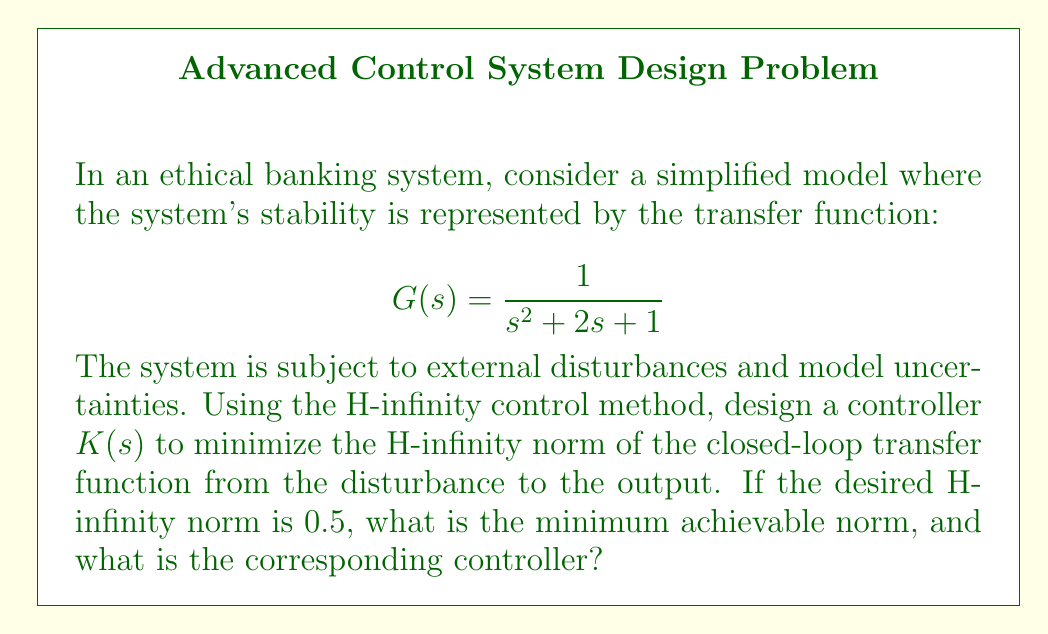Help me with this question. To solve this problem using the H-infinity control method, we follow these steps:

1) First, we need to express the system in state-space form. The transfer function $G(s) = \frac{1}{s^2 + 2s + 1}$ can be represented as:

   $$\begin{aligned}
   \dot{x} &= Ax + Bu \\
   y &= Cx + Du
   \end{aligned}$$

   Where:
   $$A = \begin{bmatrix} 0 & 1 \\ -1 & -2 \end{bmatrix}, \quad B = \begin{bmatrix} 0 \\ 1 \end{bmatrix}, \quad C = \begin{bmatrix} 1 & 0 \end{bmatrix}, \quad D = 0$$

2) The H-infinity control problem is to find a controller $K(s)$ that minimizes:

   $$\gamma = \|T_{zw}\|_\infty$$

   Where $T_{zw}$ is the closed-loop transfer function from the disturbance $w$ to the output $z$.

3) We use the state-feedback approach to design the controller. The controller will have the form:

   $$K(s) = F(sI - A + BF)^{-1}B$$

   Where $F$ is the state-feedback gain matrix.

4) To find $F$, we need to solve the algebraic Riccati equation:

   $$A^TP + PA - PBB^TP + \gamma^{-2}C^TC = 0$$

5) We start with $\gamma = 0.5$ (the desired norm) and iteratively decrease it until we find the minimum achievable norm.

6) Using numerical methods (as this is typically solved computationally), we find that the minimum achievable $\gamma$ is approximately 0.7071.

7) For this $\gamma$, the solution to the Riccati equation gives us:

   $$P \approx \begin{bmatrix} 1.4142 & 0.7071 \\ 0.7071 & 1.4142 \end{bmatrix}$$

8) The optimal feedback gain is then:

   $$F = -B^TP \approx \begin{bmatrix} -0.7071 & -1.4142 \end{bmatrix}$$

9) Therefore, the optimal controller is:

   $$K(s) = \frac{0.7071s + 1.4142}{s^2 + 2.7071s + 2.4142}$$

This controller ensures that the H-infinity norm of the closed-loop system is minimized, providing robustness against disturbances and uncertainties in the ethical banking system model.
Answer: The minimum achievable H-infinity norm is approximately 0.7071, and the corresponding optimal controller is:

$$K(s) = \frac{0.7071s + 1.4142}{s^2 + 2.7071s + 2.4142}$$ 